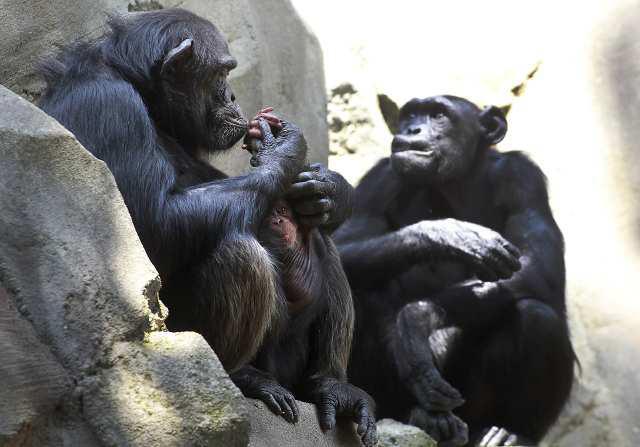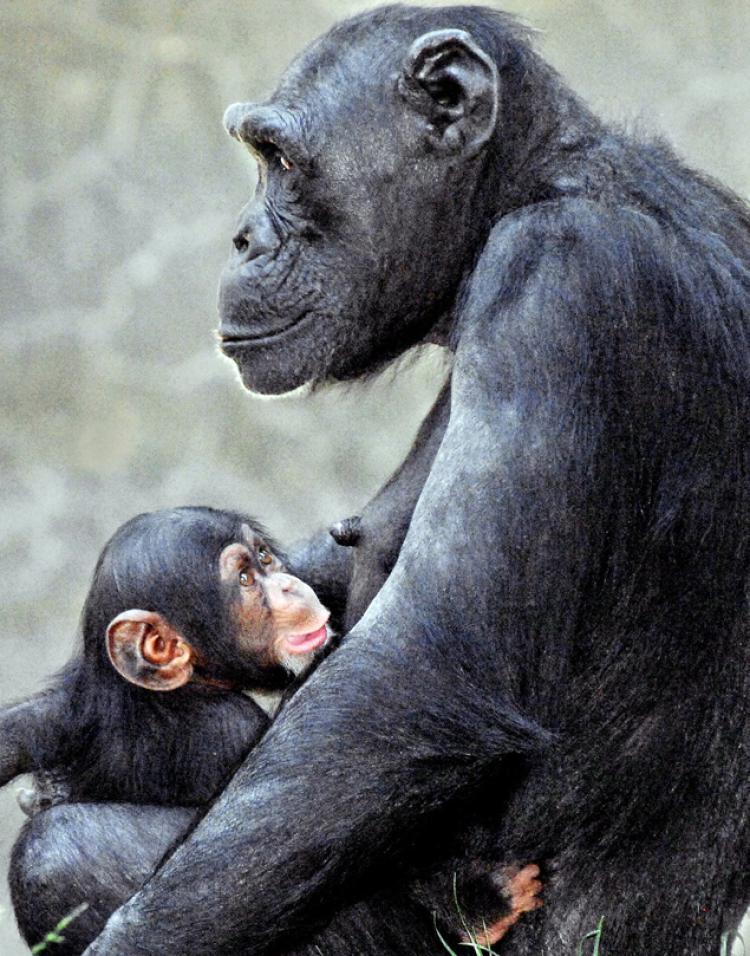The first image is the image on the left, the second image is the image on the right. Analyze the images presented: Is the assertion "The right image shows an adult chimp sitting upright, with a baby held in front." valid? Answer yes or no. Yes. 